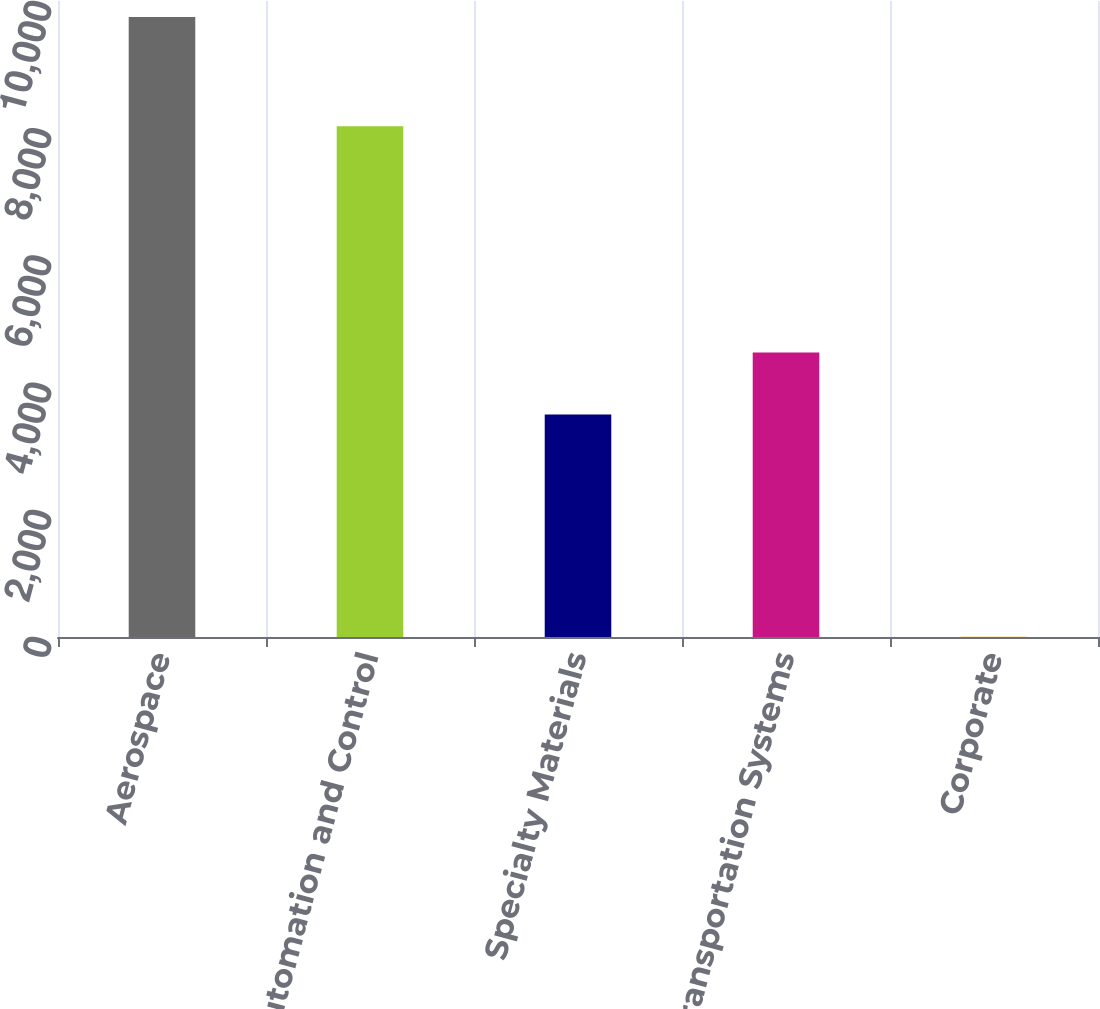<chart> <loc_0><loc_0><loc_500><loc_500><bar_chart><fcel>Aerospace<fcel>Automation and Control<fcel>Specialty Materials<fcel>Transportation Systems<fcel>Corporate<nl><fcel>9748<fcel>8031<fcel>3497<fcel>4471.6<fcel>2<nl></chart> 